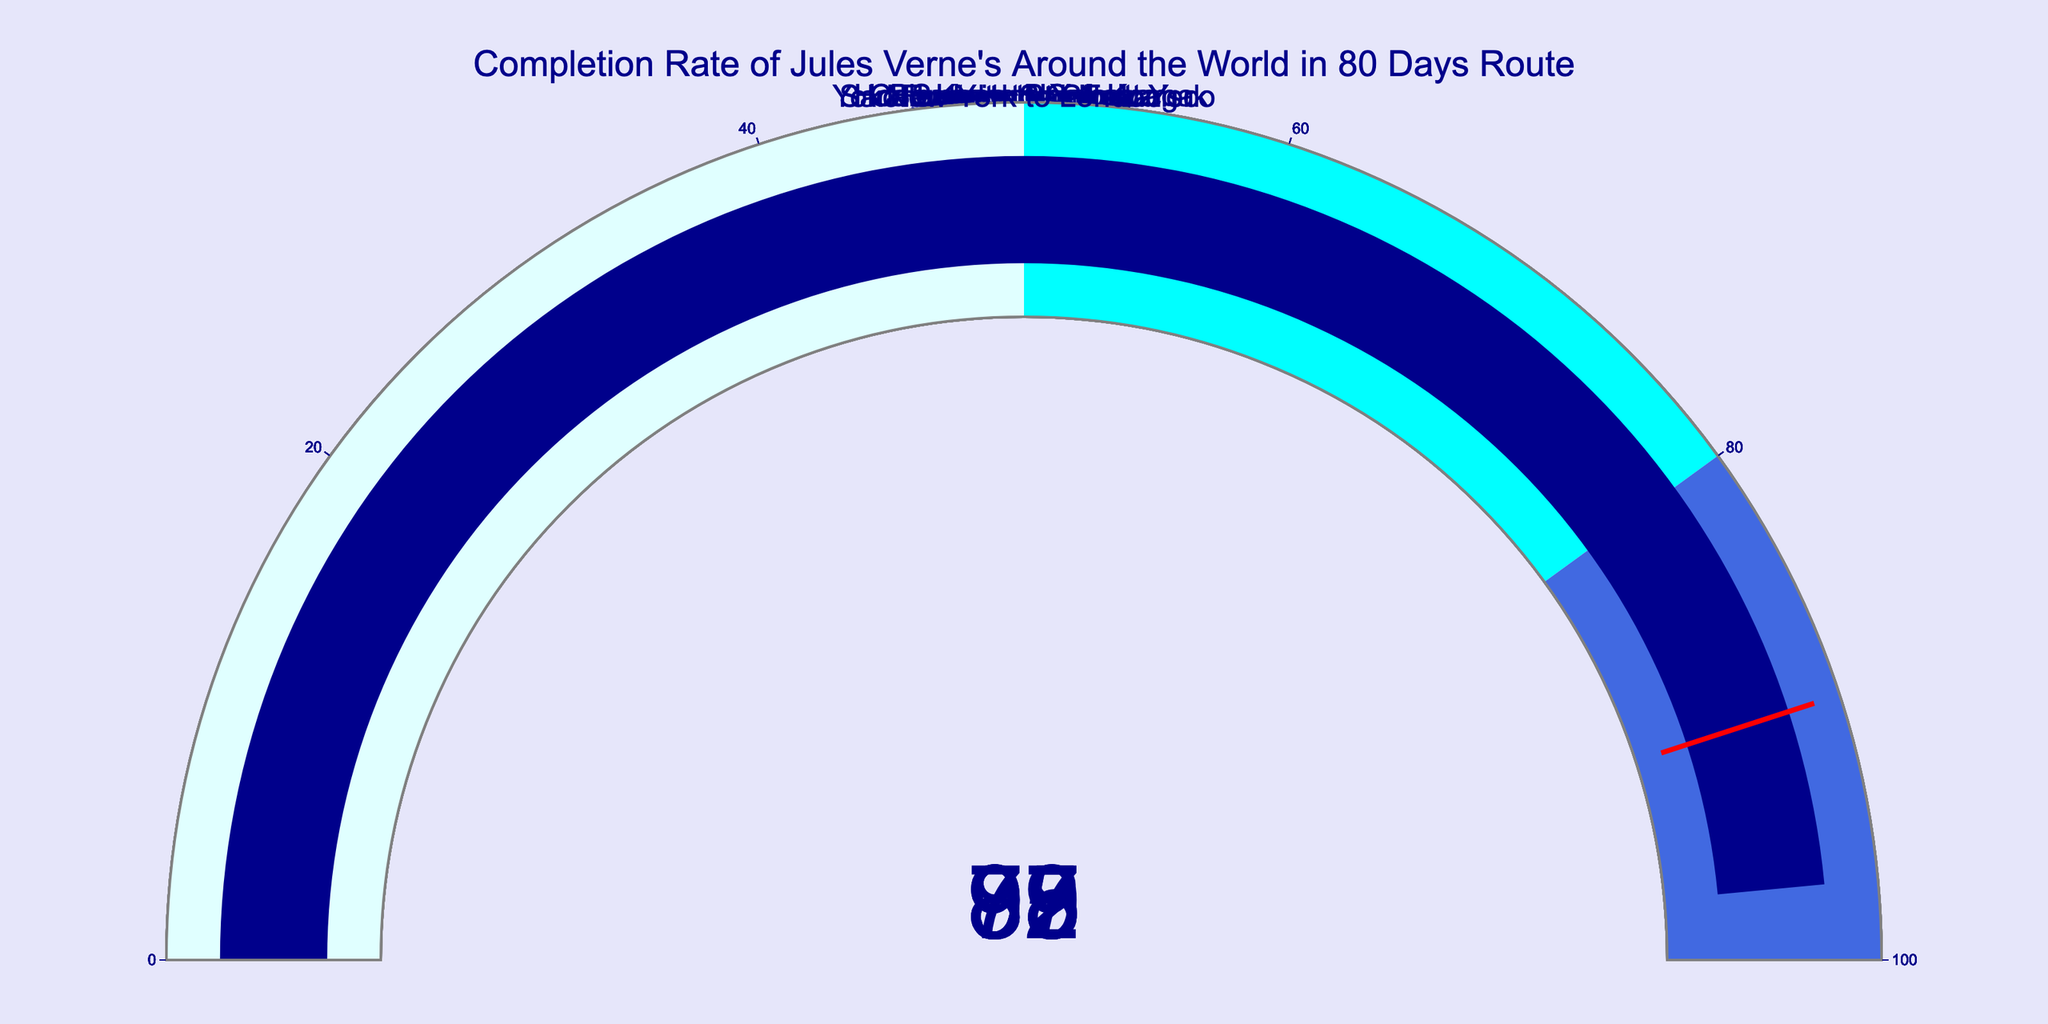What is the title of the figure? The title of the figure is displayed at the top center in a larger font. It reads "Completion Rate of Jules Verne's Around the World in 80 Days Route".
Answer: Completion Rate of Jules Verne's Around the World in 80 Days Route How many gauge charts are displayed in the figure? By counting the number of distinct gauge charts shown in the layout, which is arranged in a 2x4 grid format, it is evident that there are 8 gauges.
Answer: 8 Which route has the highest completion rate? To determine the highest completion rate, scan through each gauge and observe which one has the highest number. The gauge for "New York to London" shows the value 97, which is the highest.
Answer: New York to London Which route has a completion rate below 80%? By examining the values in each gauge chart, the route "Bombay to Calcutta" has a completion rate of 78%, which is the only one below 80%.
Answer: Bombay to Calcutta What is the average completion rate across all routes? To find the average completion rate, add all the completion rates and divide by the number of routes. The rates are 85, 92, 78, 88, 95, 89, 93, and 97. Sum: 717. Average = 717 / 8 = 89.63
Answer: 89.63 Compare the completion rate of "San Francisco to New York" and "London to Suez". Which is higher and by how much? First, note the values: "San Francisco to New York" is 93 and "London to Suez" is 85. Subtract the smaller number from the larger one: 93 - 85 = 8.
Answer: San Francisco to New York by 8 Are there any routes that have a completion rate exactly equal to 90%? By examining each gauge, none of the routes show a completion rate of exactly 90%. They are all either above or below that value.
Answer: No Calculate the total completion rate for the routes with more than 90%. Identify the gauges with completion rates more than 90%: 92, 95, 93, and 97. Sum these values: 92 + 95 + 93 + 97 = 377.
Answer: 377 